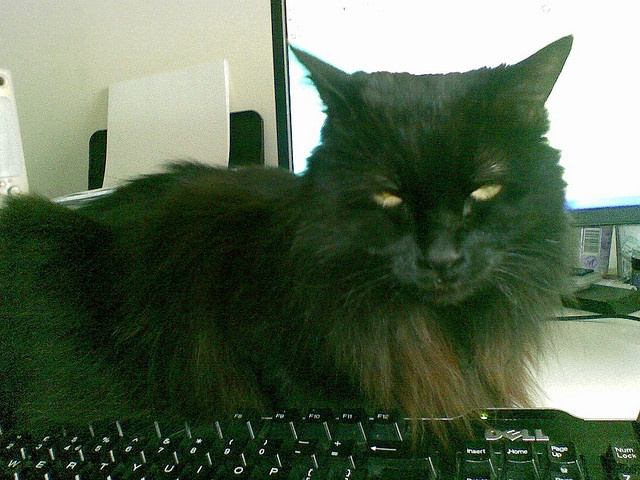Describe the objects in this image and their specific colors. I can see cat in lightgray, black, and darkgreen tones and keyboard in lightgray, black, darkgreen, and gray tones in this image. 